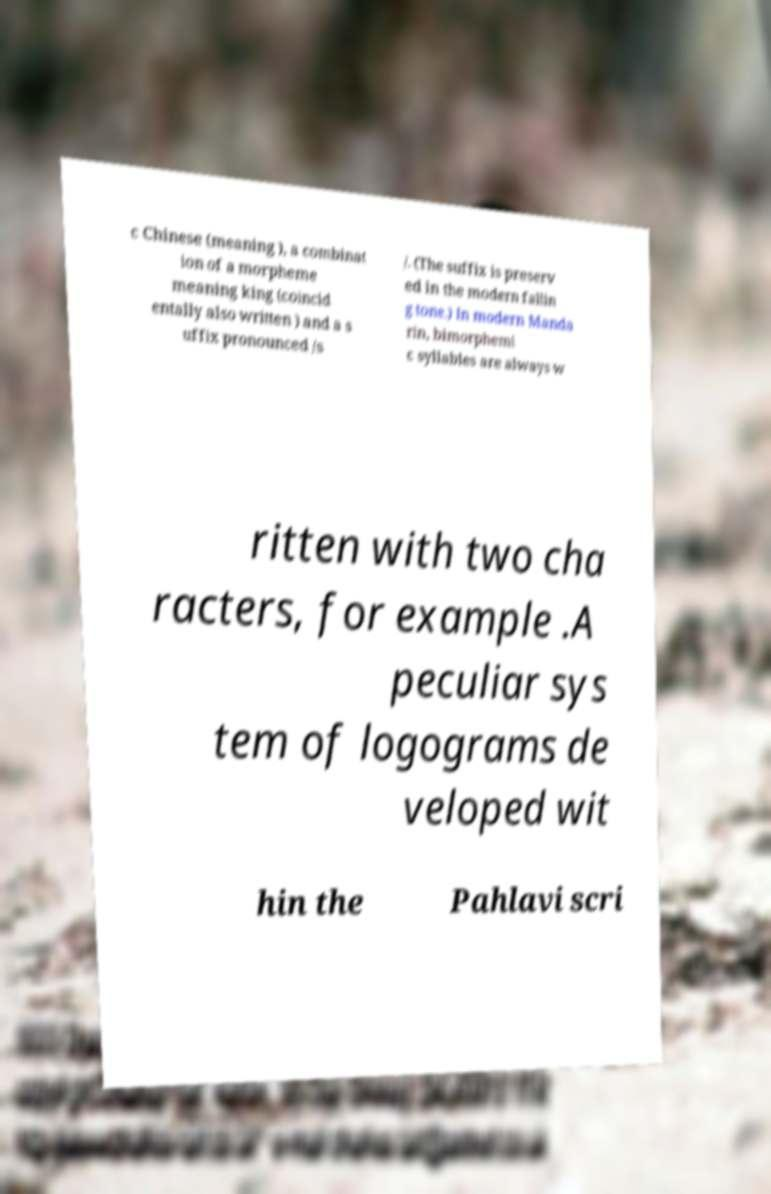Please read and relay the text visible in this image. What does it say? c Chinese (meaning ), a combinat ion of a morpheme meaning king (coincid entally also written ) and a s uffix pronounced /s /. (The suffix is preserv ed in the modern fallin g tone.) In modern Manda rin, bimorphemi c syllables are always w ritten with two cha racters, for example .A peculiar sys tem of logograms de veloped wit hin the Pahlavi scri 